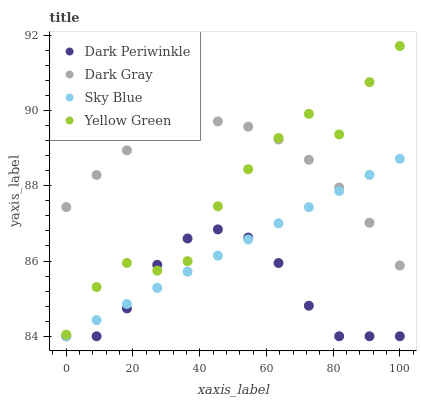Does Dark Periwinkle have the minimum area under the curve?
Answer yes or no. Yes. Does Dark Gray have the maximum area under the curve?
Answer yes or no. Yes. Does Sky Blue have the minimum area under the curve?
Answer yes or no. No. Does Sky Blue have the maximum area under the curve?
Answer yes or no. No. Is Sky Blue the smoothest?
Answer yes or no. Yes. Is Yellow Green the roughest?
Answer yes or no. Yes. Is Dark Periwinkle the smoothest?
Answer yes or no. No. Is Dark Periwinkle the roughest?
Answer yes or no. No. Does Sky Blue have the lowest value?
Answer yes or no. Yes. Does Yellow Green have the lowest value?
Answer yes or no. No. Does Yellow Green have the highest value?
Answer yes or no. Yes. Does Sky Blue have the highest value?
Answer yes or no. No. Is Sky Blue less than Yellow Green?
Answer yes or no. Yes. Is Yellow Green greater than Sky Blue?
Answer yes or no. Yes. Does Dark Periwinkle intersect Yellow Green?
Answer yes or no. Yes. Is Dark Periwinkle less than Yellow Green?
Answer yes or no. No. Is Dark Periwinkle greater than Yellow Green?
Answer yes or no. No. Does Sky Blue intersect Yellow Green?
Answer yes or no. No. 